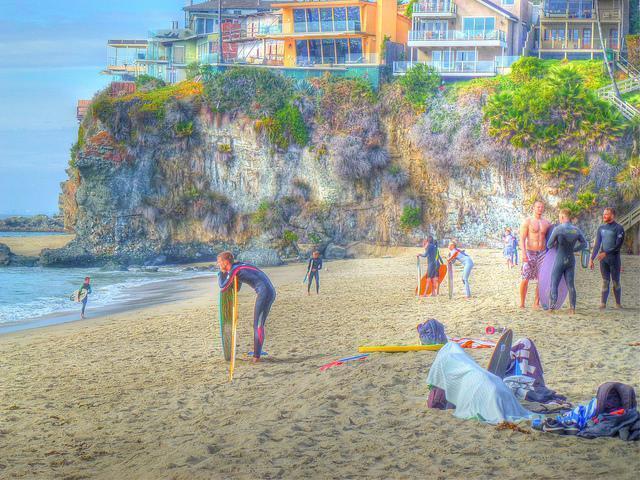What is this image?
Choose the correct response, then elucidate: 'Answer: answer
Rationale: rationale.'
Options: Puzzle, photo, photoshopped picture, drawing. Answer: drawing.
Rationale: You can see the brush strokes 